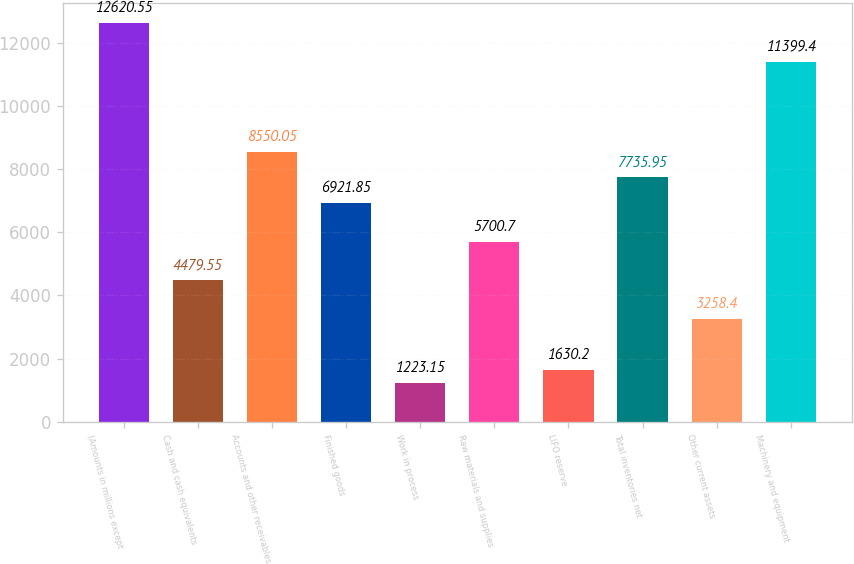<chart> <loc_0><loc_0><loc_500><loc_500><bar_chart><fcel>(Amounts in millions except<fcel>Cash and cash equivalents<fcel>Accounts and other receivables<fcel>Finished goods<fcel>Work in process<fcel>Raw materials and supplies<fcel>LIFO reserve<fcel>Total inventories net<fcel>Other current assets<fcel>Machinery and equipment<nl><fcel>12620.5<fcel>4479.55<fcel>8550.05<fcel>6921.85<fcel>1223.15<fcel>5700.7<fcel>1630.2<fcel>7735.95<fcel>3258.4<fcel>11399.4<nl></chart> 